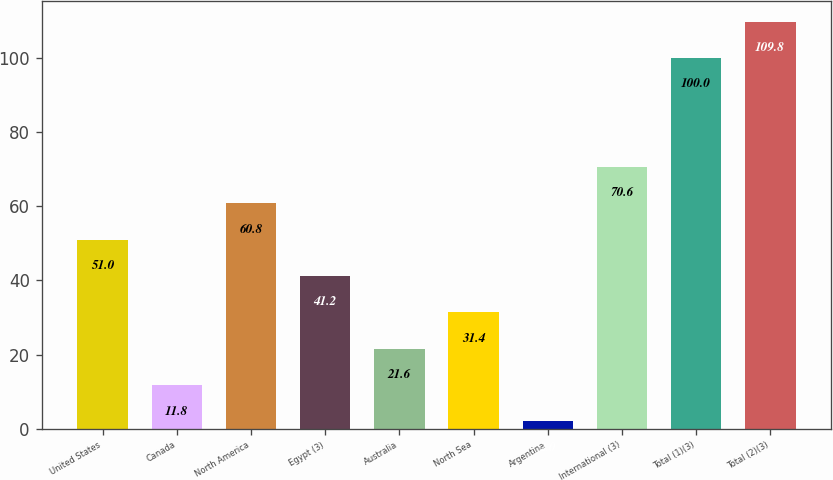<chart> <loc_0><loc_0><loc_500><loc_500><bar_chart><fcel>United States<fcel>Canada<fcel>North America<fcel>Egypt (3)<fcel>Australia<fcel>North Sea<fcel>Argentina<fcel>International (3)<fcel>Total (1)(3)<fcel>Total (2)(3)<nl><fcel>51<fcel>11.8<fcel>60.8<fcel>41.2<fcel>21.6<fcel>31.4<fcel>2<fcel>70.6<fcel>100<fcel>109.8<nl></chart> 